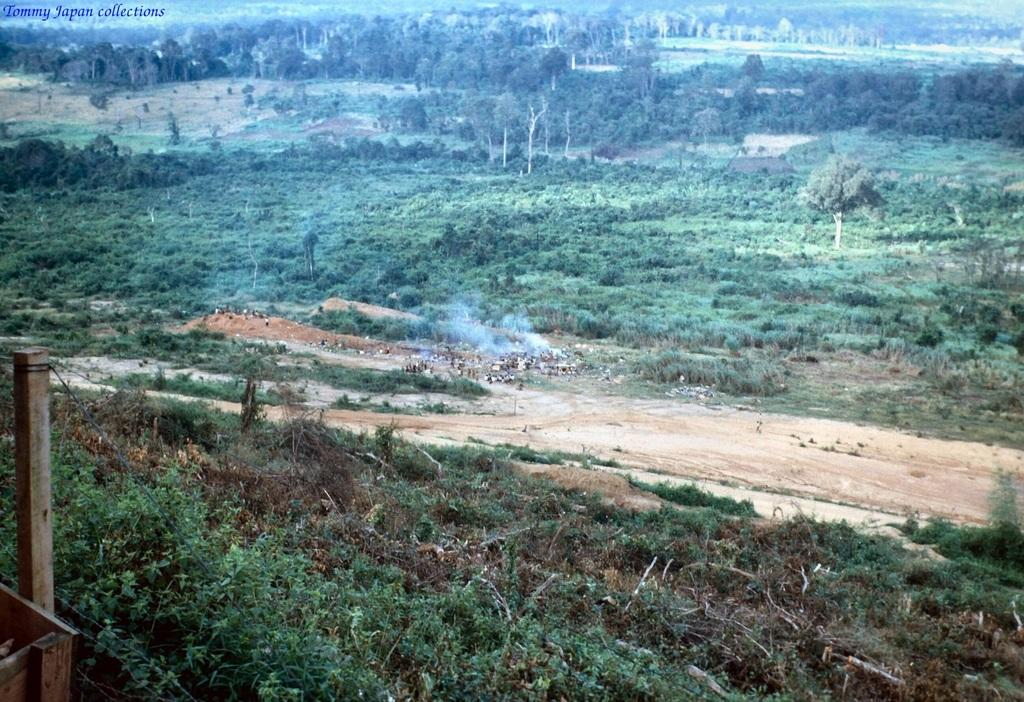What type of vegetation can be seen in the image? There are trees in the image. Are there any living beings in the image? Yes, there are people in the image. What is the ground covered with in the image? Grass is present on the ground in the image. What type of tomatoes can be seen growing on the trees in the image? There are no tomatoes present in the image, and the trees are not mentioned as bearing fruit. 